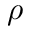<formula> <loc_0><loc_0><loc_500><loc_500>\rho</formula> 